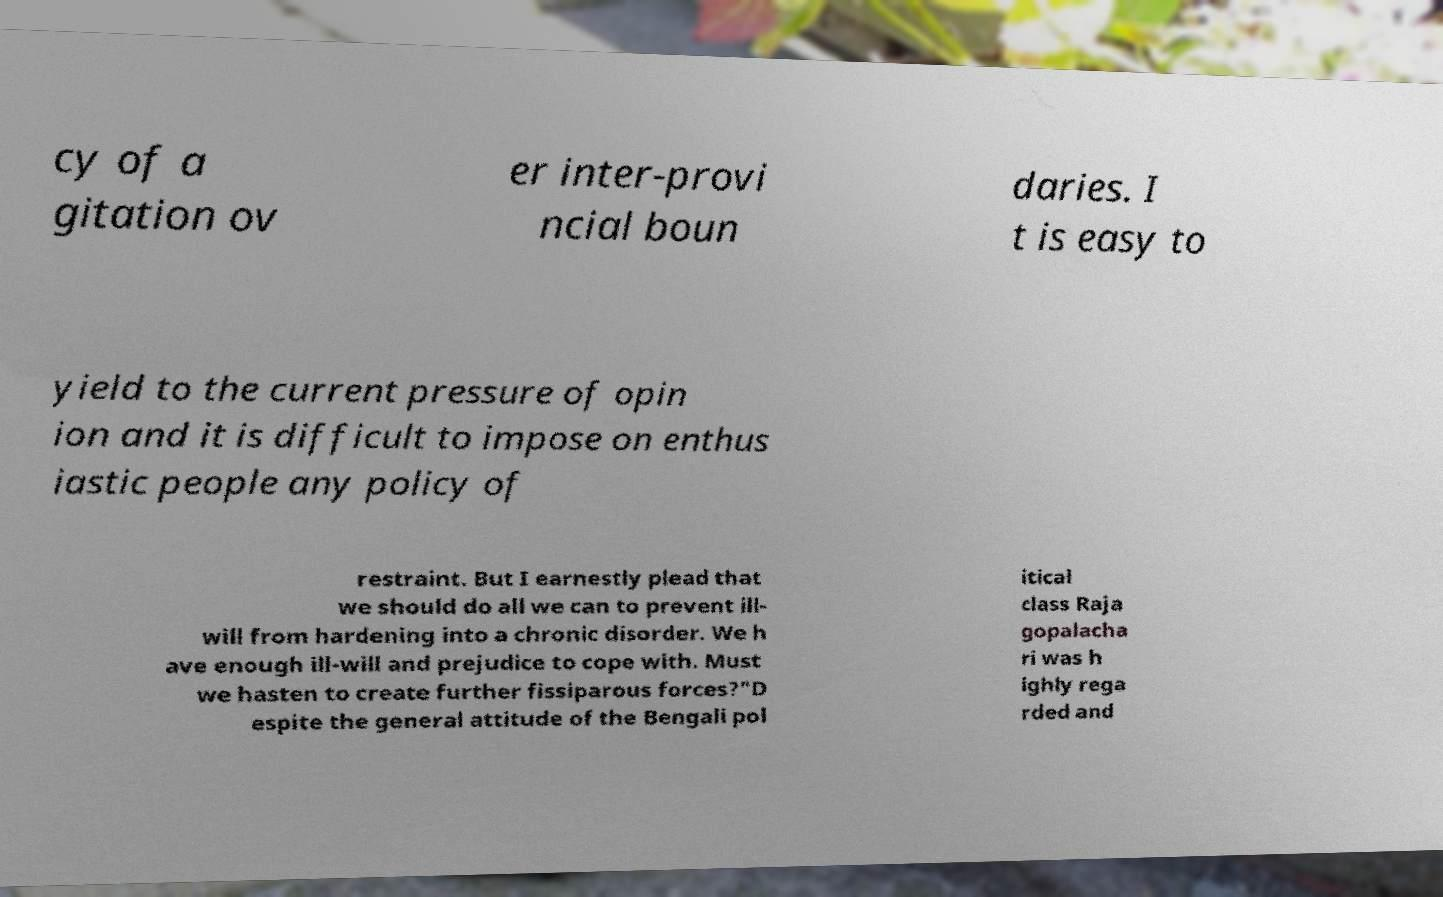What messages or text are displayed in this image? I need them in a readable, typed format. cy of a gitation ov er inter-provi ncial boun daries. I t is easy to yield to the current pressure of opin ion and it is difficult to impose on enthus iastic people any policy of restraint. But I earnestly plead that we should do all we can to prevent ill- will from hardening into a chronic disorder. We h ave enough ill-will and prejudice to cope with. Must we hasten to create further fissiparous forces?"D espite the general attitude of the Bengali pol itical class Raja gopalacha ri was h ighly rega rded and 